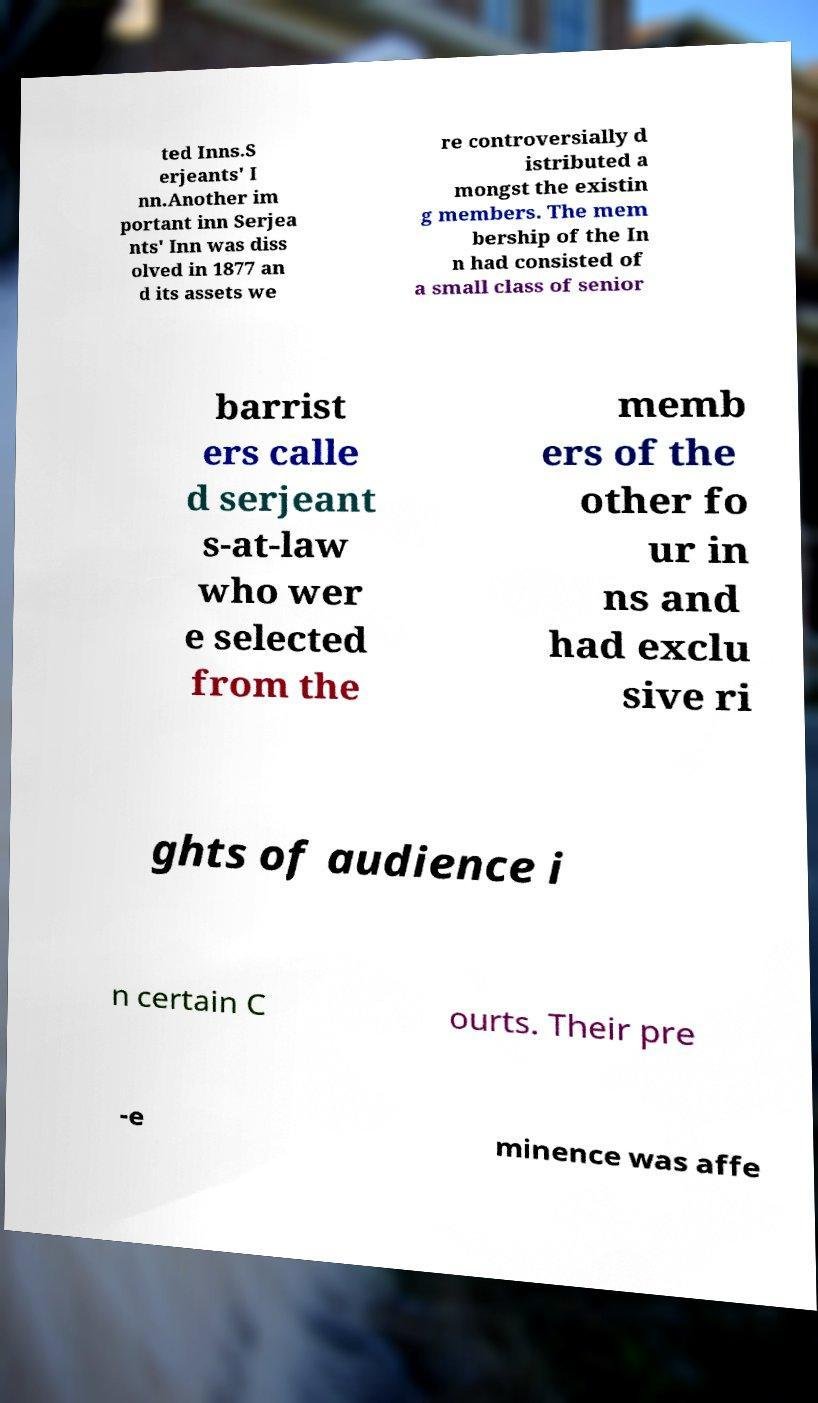Could you assist in decoding the text presented in this image and type it out clearly? ted Inns.S erjeants' I nn.Another im portant inn Serjea nts' Inn was diss olved in 1877 an d its assets we re controversially d istributed a mongst the existin g members. The mem bership of the In n had consisted of a small class of senior barrist ers calle d serjeant s-at-law who wer e selected from the memb ers of the other fo ur in ns and had exclu sive ri ghts of audience i n certain C ourts. Their pre -e minence was affe 